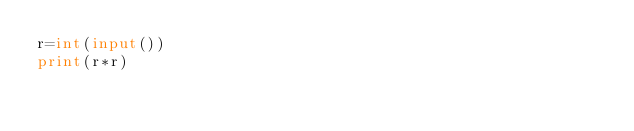Convert code to text. <code><loc_0><loc_0><loc_500><loc_500><_Python_>r=int(input())
print(r*r)</code> 